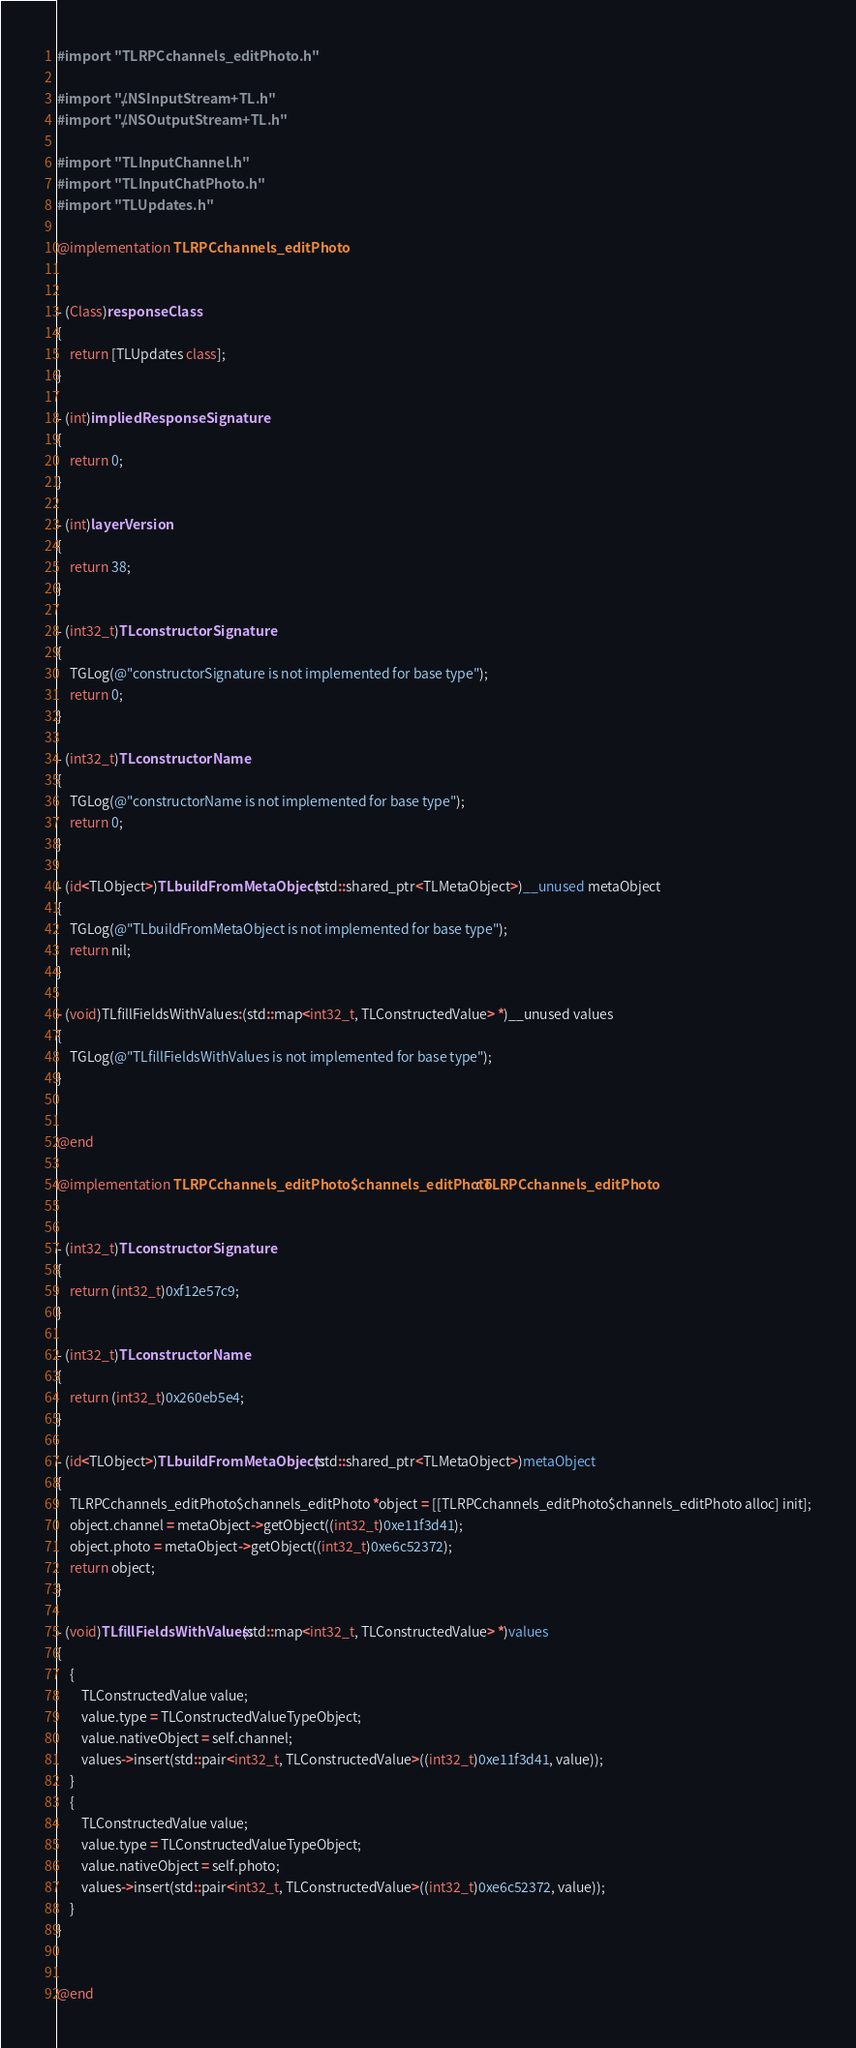<code> <loc_0><loc_0><loc_500><loc_500><_ObjectiveC_>#import "TLRPCchannels_editPhoto.h"

#import "../NSInputStream+TL.h"
#import "../NSOutputStream+TL.h"

#import "TLInputChannel.h"
#import "TLInputChatPhoto.h"
#import "TLUpdates.h"

@implementation TLRPCchannels_editPhoto


- (Class)responseClass
{
    return [TLUpdates class];
}

- (int)impliedResponseSignature
{
    return 0;
}

- (int)layerVersion
{
    return 38;
}

- (int32_t)TLconstructorSignature
{
    TGLog(@"constructorSignature is not implemented for base type");
    return 0;
}

- (int32_t)TLconstructorName
{
    TGLog(@"constructorName is not implemented for base type");
    return 0;
}

- (id<TLObject>)TLbuildFromMetaObject:(std::shared_ptr<TLMetaObject>)__unused metaObject
{
    TGLog(@"TLbuildFromMetaObject is not implemented for base type");
    return nil;
}

- (void)TLfillFieldsWithValues:(std::map<int32_t, TLConstructedValue> *)__unused values
{
    TGLog(@"TLfillFieldsWithValues is not implemented for base type");
}


@end

@implementation TLRPCchannels_editPhoto$channels_editPhoto : TLRPCchannels_editPhoto


- (int32_t)TLconstructorSignature
{
    return (int32_t)0xf12e57c9;
}

- (int32_t)TLconstructorName
{
    return (int32_t)0x260eb5e4;
}

- (id<TLObject>)TLbuildFromMetaObject:(std::shared_ptr<TLMetaObject>)metaObject
{
    TLRPCchannels_editPhoto$channels_editPhoto *object = [[TLRPCchannels_editPhoto$channels_editPhoto alloc] init];
    object.channel = metaObject->getObject((int32_t)0xe11f3d41);
    object.photo = metaObject->getObject((int32_t)0xe6c52372);
    return object;
}

- (void)TLfillFieldsWithValues:(std::map<int32_t, TLConstructedValue> *)values
{
    {
        TLConstructedValue value;
        value.type = TLConstructedValueTypeObject;
        value.nativeObject = self.channel;
        values->insert(std::pair<int32_t, TLConstructedValue>((int32_t)0xe11f3d41, value));
    }
    {
        TLConstructedValue value;
        value.type = TLConstructedValueTypeObject;
        value.nativeObject = self.photo;
        values->insert(std::pair<int32_t, TLConstructedValue>((int32_t)0xe6c52372, value));
    }
}


@end

</code> 